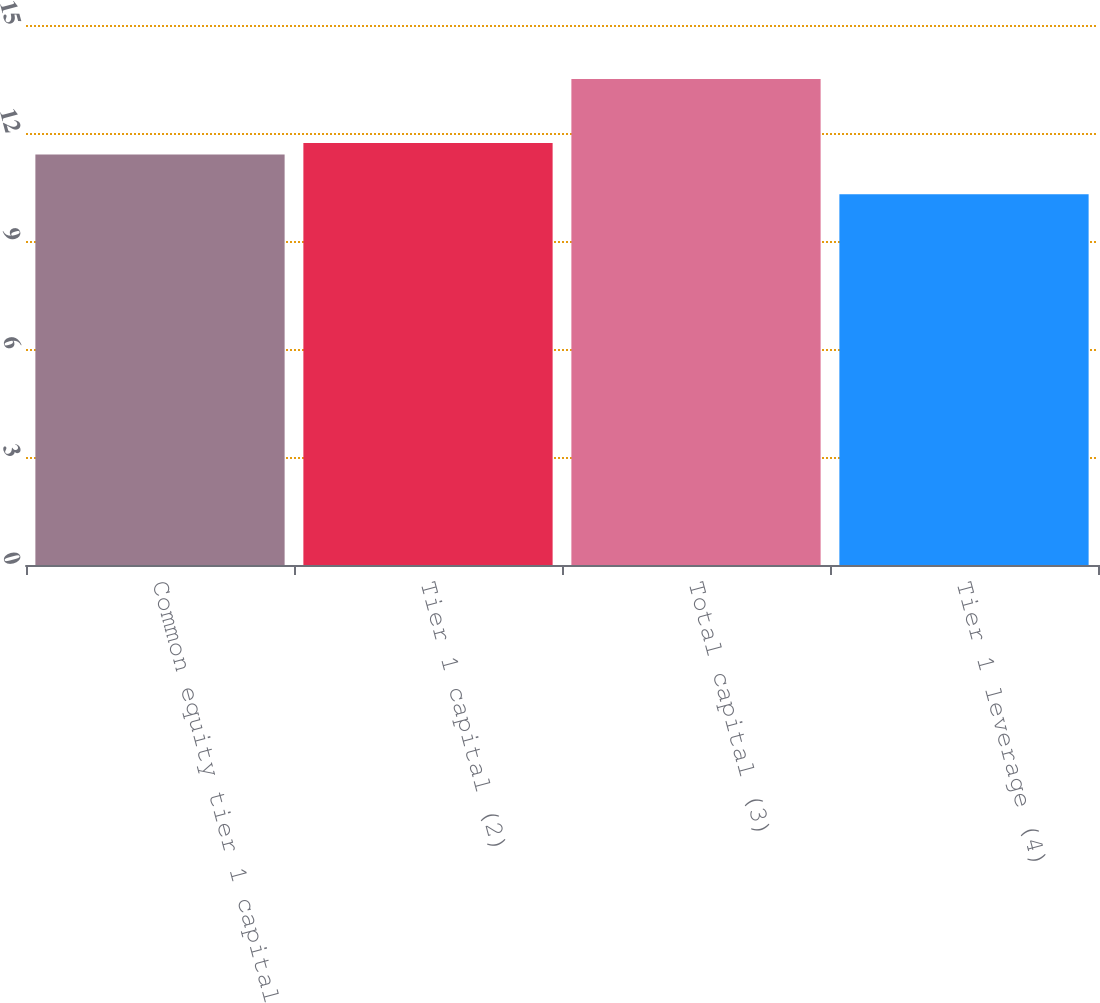Convert chart. <chart><loc_0><loc_0><loc_500><loc_500><bar_chart><fcel>Common equity tier 1 capital<fcel>Tier 1 capital (2)<fcel>Total capital (3)<fcel>Tier 1 leverage (4)<nl><fcel>11.4<fcel>11.72<fcel>13.5<fcel>10.3<nl></chart> 